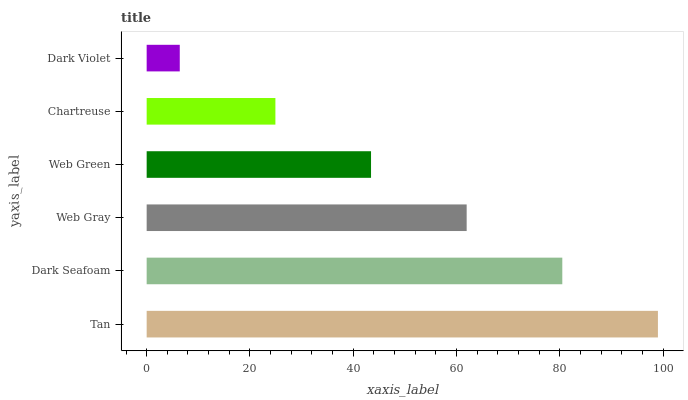Is Dark Violet the minimum?
Answer yes or no. Yes. Is Tan the maximum?
Answer yes or no. Yes. Is Dark Seafoam the minimum?
Answer yes or no. No. Is Dark Seafoam the maximum?
Answer yes or no. No. Is Tan greater than Dark Seafoam?
Answer yes or no. Yes. Is Dark Seafoam less than Tan?
Answer yes or no. Yes. Is Dark Seafoam greater than Tan?
Answer yes or no. No. Is Tan less than Dark Seafoam?
Answer yes or no. No. Is Web Gray the high median?
Answer yes or no. Yes. Is Web Green the low median?
Answer yes or no. Yes. Is Dark Violet the high median?
Answer yes or no. No. Is Web Gray the low median?
Answer yes or no. No. 